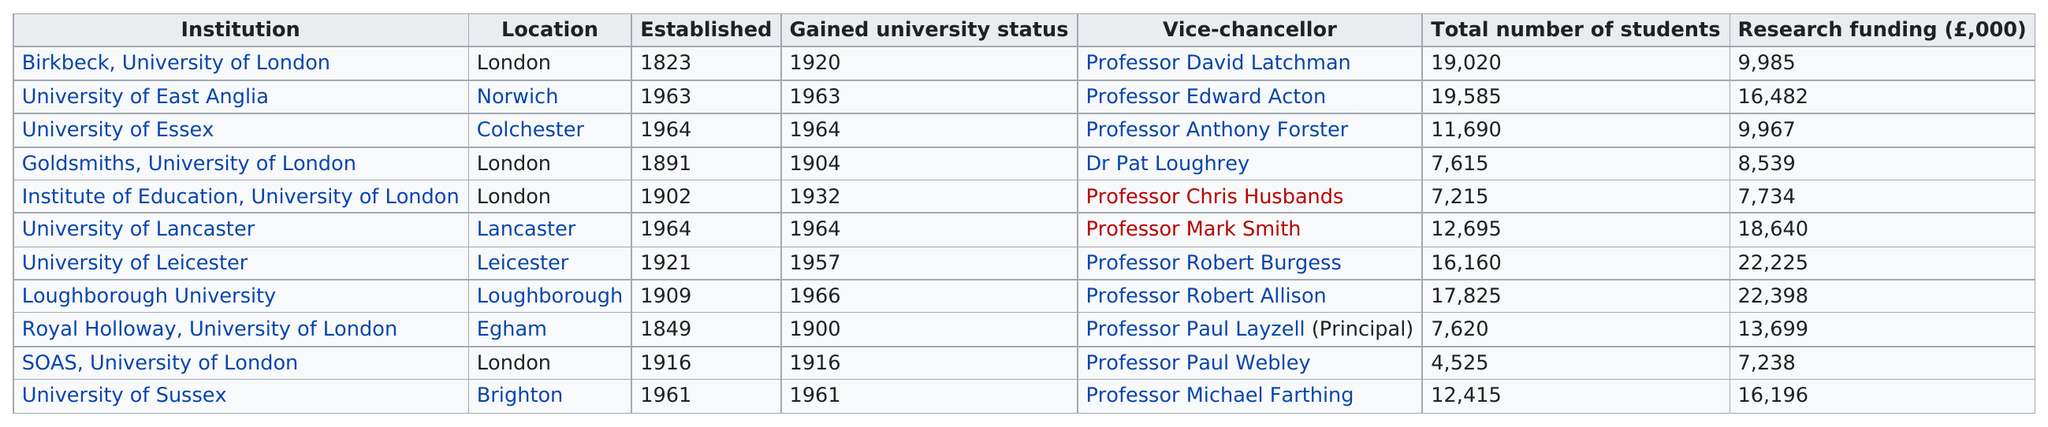List a handful of essential elements in this visual. How many of the institutions are located in London? Four of them are located in London. Loughborough University, which was most recently established as a university, is a renowned institution known for its excellence in education. The University of Essex was granted university status in 1964. Loughborough University is the institution that receives the most research funding. 